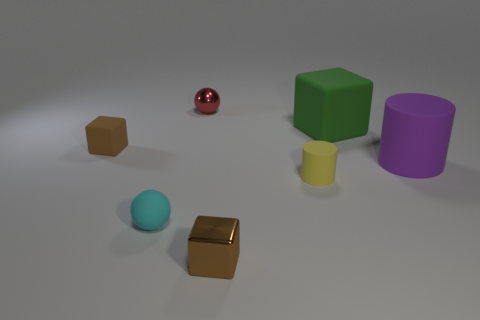Subtract all small cubes. How many cubes are left? 1 Subtract 2 blocks. How many blocks are left? 1 Add 3 big purple shiny cylinders. How many objects exist? 10 Subtract all balls. How many objects are left? 5 Subtract all brown cubes. How many cubes are left? 1 Add 4 large purple rubber things. How many large purple rubber things are left? 5 Add 5 large things. How many large things exist? 7 Subtract 0 green balls. How many objects are left? 7 Subtract all green blocks. Subtract all brown balls. How many blocks are left? 2 Subtract all purple cylinders. How many purple cubes are left? 0 